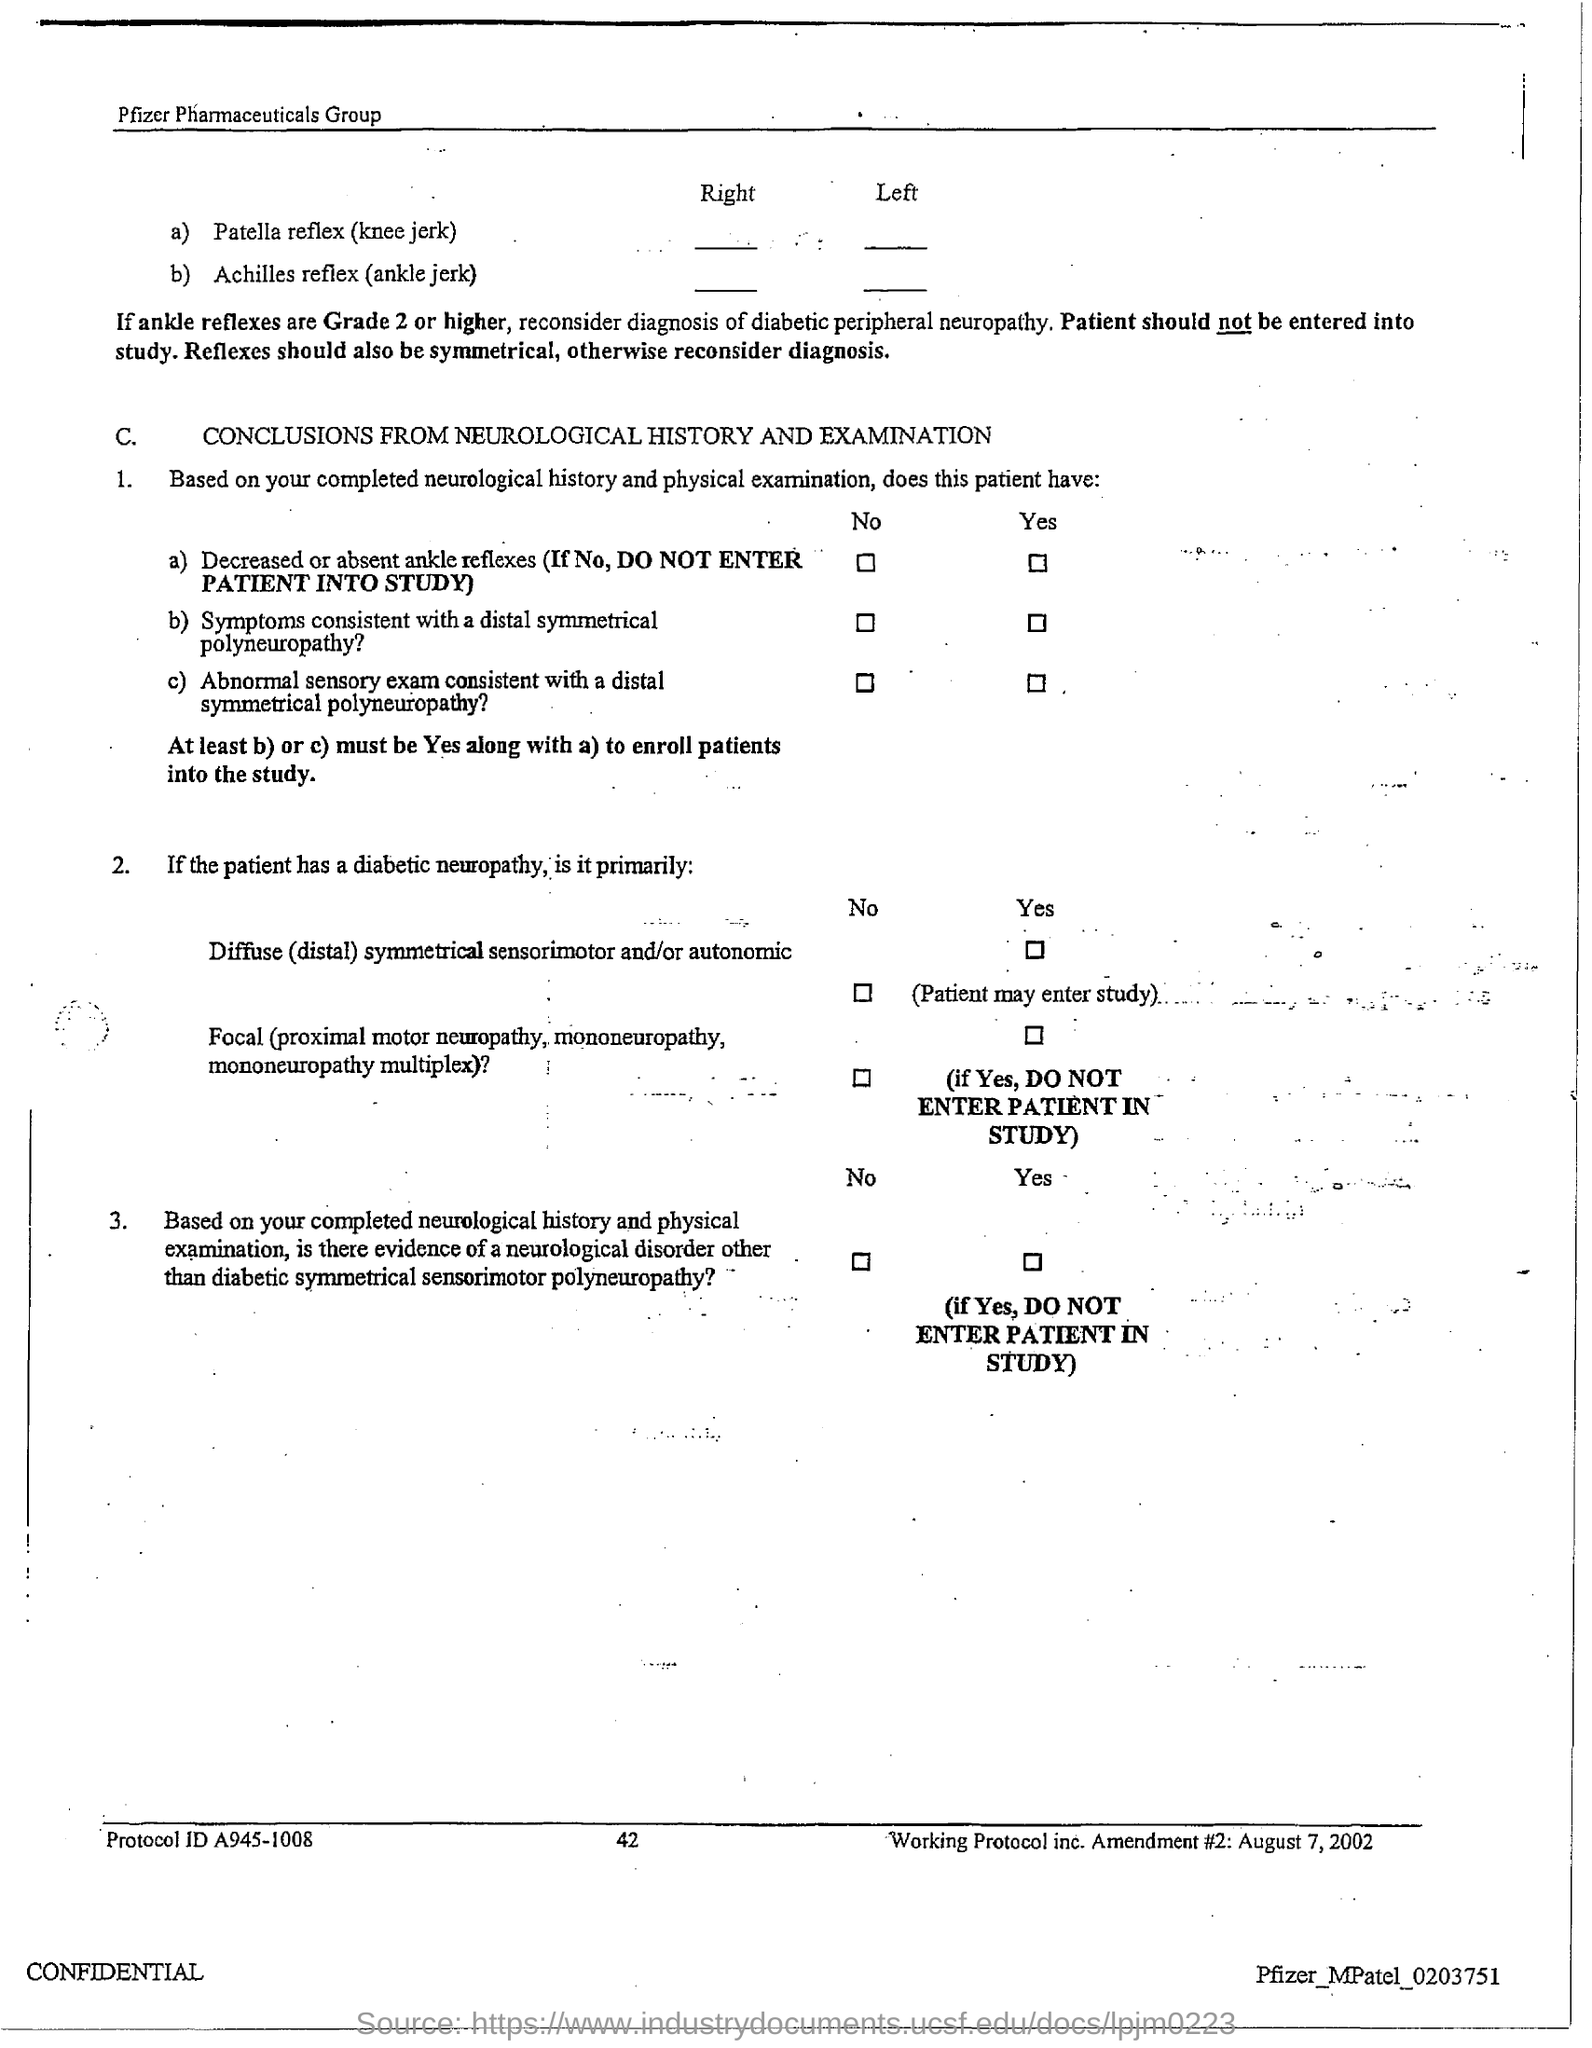What is the page no mentioned in this document?
Your answer should be compact. 42. What is the Protocol ID given in the document?
Offer a terse response. A945-1008. 